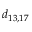Convert formula to latex. <formula><loc_0><loc_0><loc_500><loc_500>d _ { 1 3 , 1 7 }</formula> 